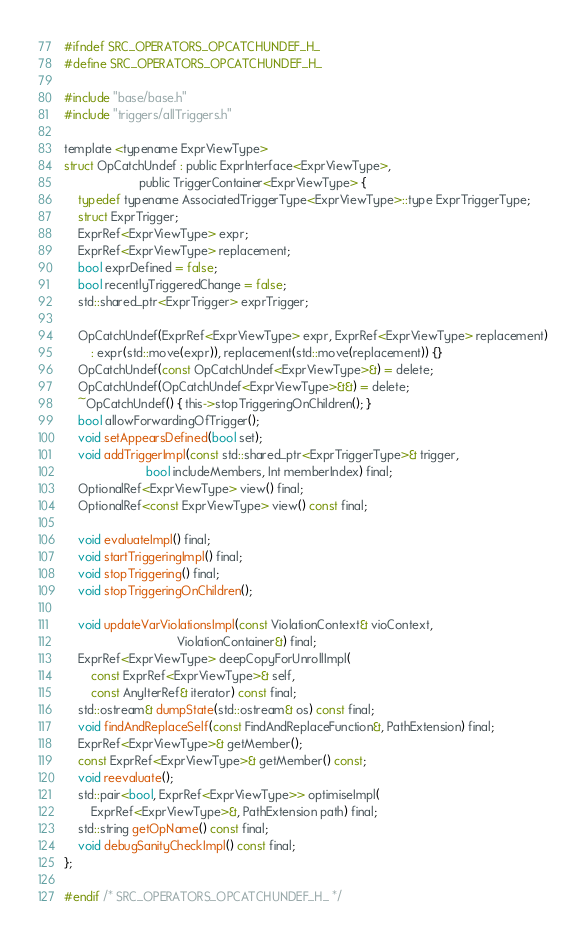Convert code to text. <code><loc_0><loc_0><loc_500><loc_500><_C_>
#ifndef SRC_OPERATORS_OPCATCHUNDEF_H_
#define SRC_OPERATORS_OPCATCHUNDEF_H_

#include "base/base.h"
#include "triggers/allTriggers.h"

template <typename ExprViewType>
struct OpCatchUndef : public ExprInterface<ExprViewType>,
                      public TriggerContainer<ExprViewType> {
    typedef typename AssociatedTriggerType<ExprViewType>::type ExprTriggerType;
    struct ExprTrigger;
    ExprRef<ExprViewType> expr;
    ExprRef<ExprViewType> replacement;
    bool exprDefined = false;
    bool recentlyTriggeredChange = false;
    std::shared_ptr<ExprTrigger> exprTrigger;

    OpCatchUndef(ExprRef<ExprViewType> expr, ExprRef<ExprViewType> replacement)
        : expr(std::move(expr)), replacement(std::move(replacement)) {}
    OpCatchUndef(const OpCatchUndef<ExprViewType>&) = delete;
    OpCatchUndef(OpCatchUndef<ExprViewType>&&) = delete;
    ~OpCatchUndef() { this->stopTriggeringOnChildren(); }
    bool allowForwardingOfTrigger();
    void setAppearsDefined(bool set);
    void addTriggerImpl(const std::shared_ptr<ExprTriggerType>& trigger,
                        bool includeMembers, Int memberIndex) final;
    OptionalRef<ExprViewType> view() final;
    OptionalRef<const ExprViewType> view() const final;

    void evaluateImpl() final;
    void startTriggeringImpl() final;
    void stopTriggering() final;
    void stopTriggeringOnChildren();

    void updateVarViolationsImpl(const ViolationContext& vioContext,
                                 ViolationContainer&) final;
    ExprRef<ExprViewType> deepCopyForUnrollImpl(
        const ExprRef<ExprViewType>& self,
        const AnyIterRef& iterator) const final;
    std::ostream& dumpState(std::ostream& os) const final;
    void findAndReplaceSelf(const FindAndReplaceFunction&, PathExtension) final;
    ExprRef<ExprViewType>& getMember();
    const ExprRef<ExprViewType>& getMember() const;
    void reevaluate();
    std::pair<bool, ExprRef<ExprViewType>> optimiseImpl(
        ExprRef<ExprViewType>&, PathExtension path) final;
    std::string getOpName() const final;
    void debugSanityCheckImpl() const final;
};

#endif /* SRC_OPERATORS_OPCATCHUNDEF_H_ */
</code> 